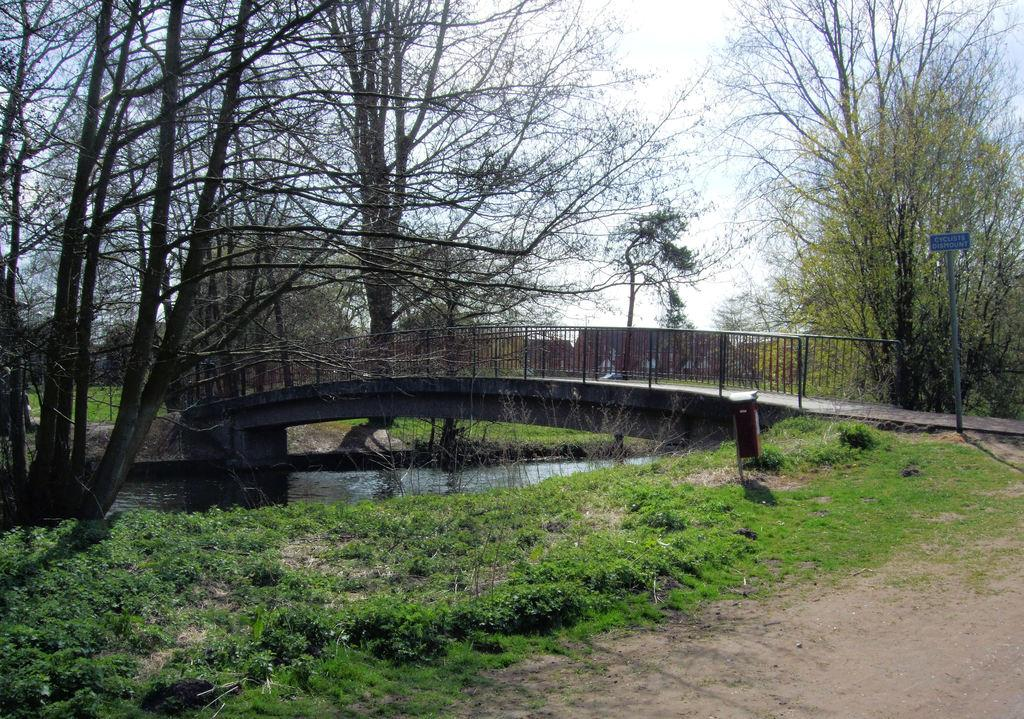What type of structure can be seen in the image? There is a bridge in the image. What type of vegetation is present in the image? There are trees and grass in the image. What natural element is visible in the image? There is water visible in the image. What type of informational sign is present in the image? There is a sign board in the image. What part of the natural environment is visible in the image? The sky is visible in the image. Can you see a whip being used to control a horse in the image? There is no whip or horse present in the image. What type of ball is being played with in the image? There is no ball or game being played in the image. 